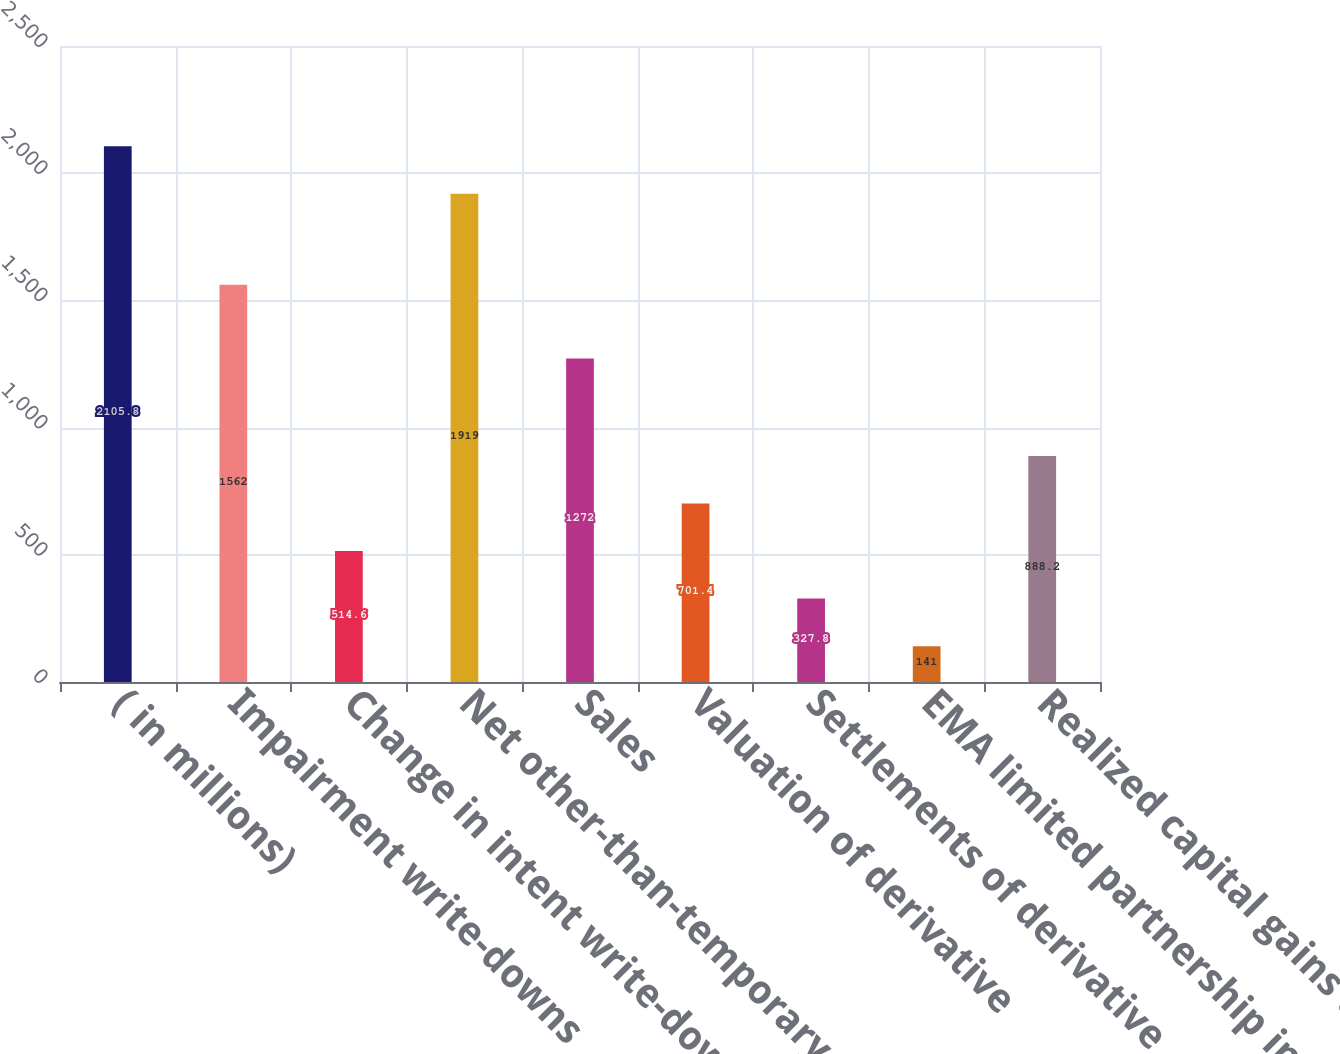<chart> <loc_0><loc_0><loc_500><loc_500><bar_chart><fcel>( in millions)<fcel>Impairment write-downs<fcel>Change in intent write-downs<fcel>Net other-than-temporary<fcel>Sales<fcel>Valuation of derivative<fcel>Settlements of derivative<fcel>EMA limited partnership income<fcel>Realized capital gains and<nl><fcel>2105.8<fcel>1562<fcel>514.6<fcel>1919<fcel>1272<fcel>701.4<fcel>327.8<fcel>141<fcel>888.2<nl></chart> 